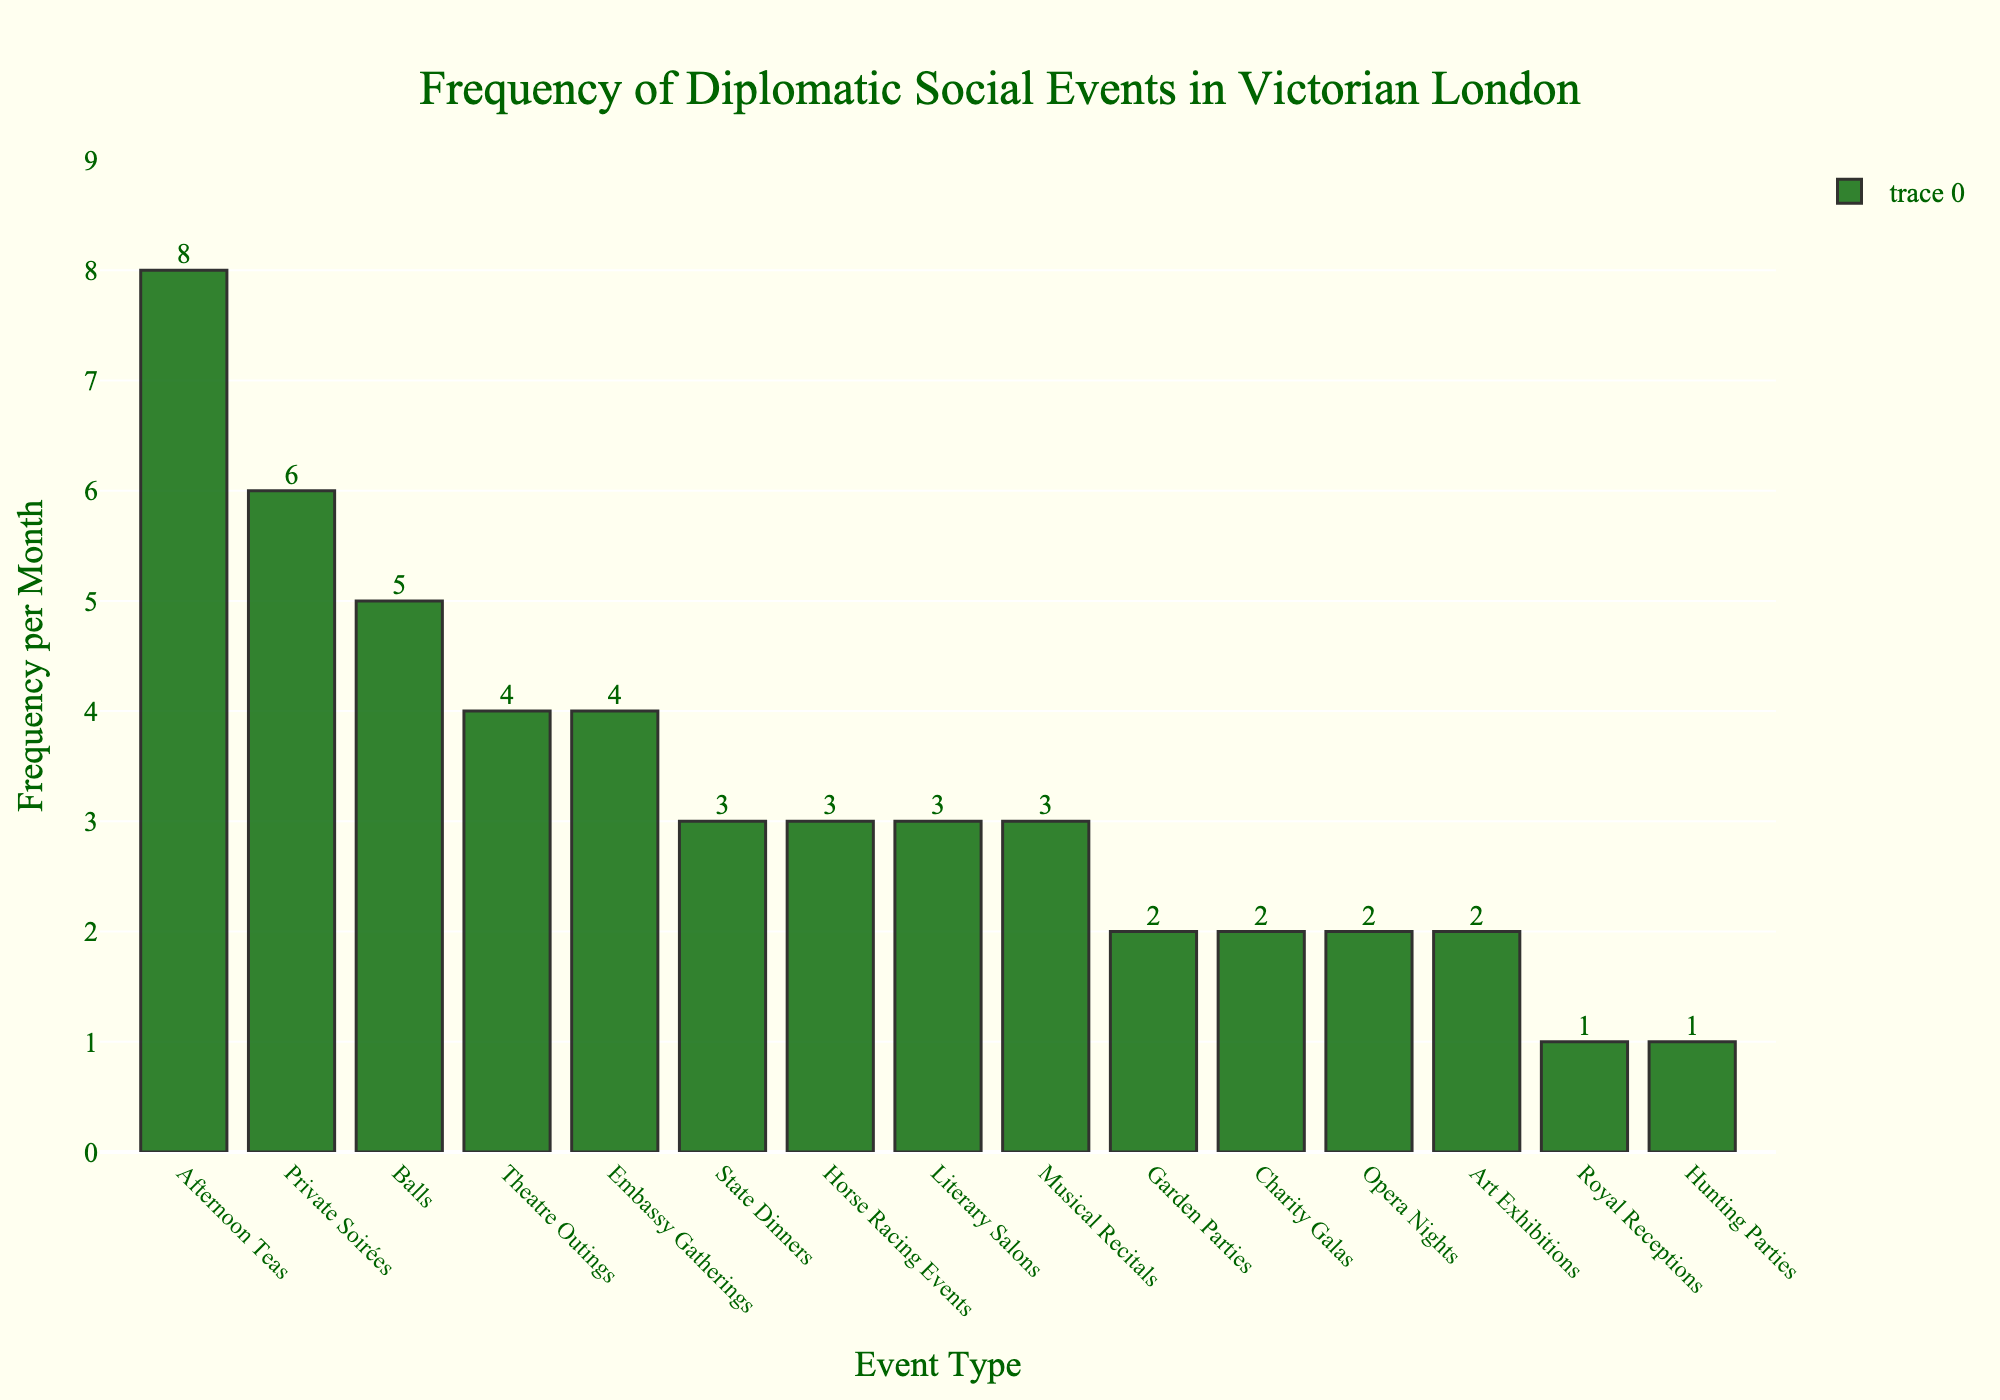Which event type has the highest frequency of attendance per month? The highest bar in the chart represents the event type with the highest frequency. Here, "Afternoon Teas" has the highest bar with a frequency of 8.
Answer: Afternoon Teas Which event type has the lowest frequency of attendance per month? The lowest bars in the chart represent the event types with the lowest frequency. Both "Royal Receptions" and "Hunting Parties" have the lowest bar with a frequency of 1.
Answer: Royal Receptions, Hunting Parties What is the total frequency of attendance for "Theatre Outings" and "Balls" combined? To find the total frequency, simply add the frequencies of "Theatre Outings" (4) and "Balls" (5). 4 + 5 = 9.
Answer: 9 Which event type has a greater frequency, "Horse Racing Events" or "Opera Nights"? By comparing the heights of the bars for "Horse Racing Events" and "Opera Nights", "Horse Racing Events" (3) is greater than "Opera Nights" (2).
Answer: Horse Racing Events How much greater is the frequency of "Private Soirées" compared to "Garden Parties"? Subtract the frequency of "Garden Parties" (2) from "Private Soirées" (6). 6 - 2 = 4.
Answer: 4 What is the average monthly frequency of attendance for "Art Exhibitions", "Charity Galas", and "Musical Recitals"? Add the frequencies of these events and divide by the number of events: (2 + 2 + 3) / 3 = 7 / 3 ≈ 2.33.
Answer: 2.33 Which event types have a frequency of exactly 3 per month? By visually scanning the chart for bars labeled with a frequency of 3, we find: "State Dinners", "Literary Salons", and "Musical Recitals".
Answer: State Dinners, Literary Salons, Musical Recitals Is the frequency of "Afternoon Teas" more than double that of "Private Soirées"? Compare whether 8 is more than twice 6 (Private Soirées' frequency). Since 8 > 2 * 6, the statement is not true.
Answer: No By how much does the frequency of "Garden Parties" exceed that of "Hunting Parties"? Subtract the frequency of "Hunting Parties" (1) from "Garden Parties" (2). 2 - 1 = 1.
Answer: 1 If diplomats started attending "Art Exhibitions" 4 times a month instead of the current frequency, how many event types would then have a frequency higher than "Art Exhibitions"? The new frequency for "Art Exhibitions" would be 4. Counting the event types that would still have a higher frequency than 4: "Afternoon Teas" (8), "Private Soirées" (6), and "Balls" (5), totaling 3 event types.
Answer: 3 